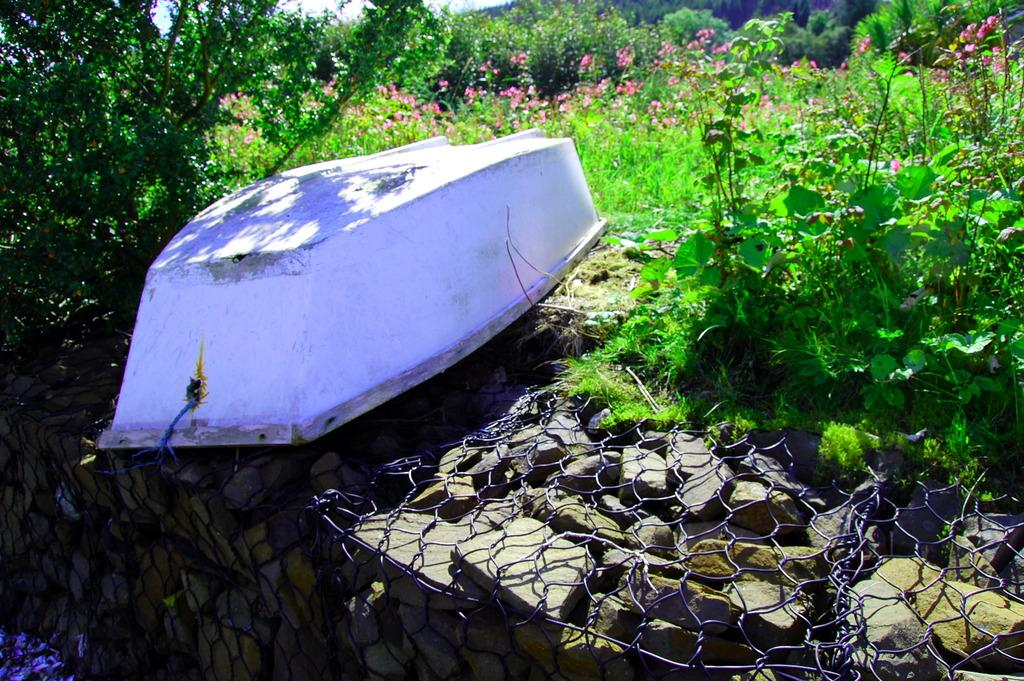What is the main object in the image that resembles a mode of transportation? There is an object that looks like a boat in the image. What type of structure can be seen on a wall in the image? There is a fence on a wall in the image. What type of plants are present in the image? There are there any flowers? What is visible in the background of the image? The sky is visible in the image. What is the time of day indicated by the smell in the image? There is no information about the smell in the image, so it cannot be used to determine the time of day. 